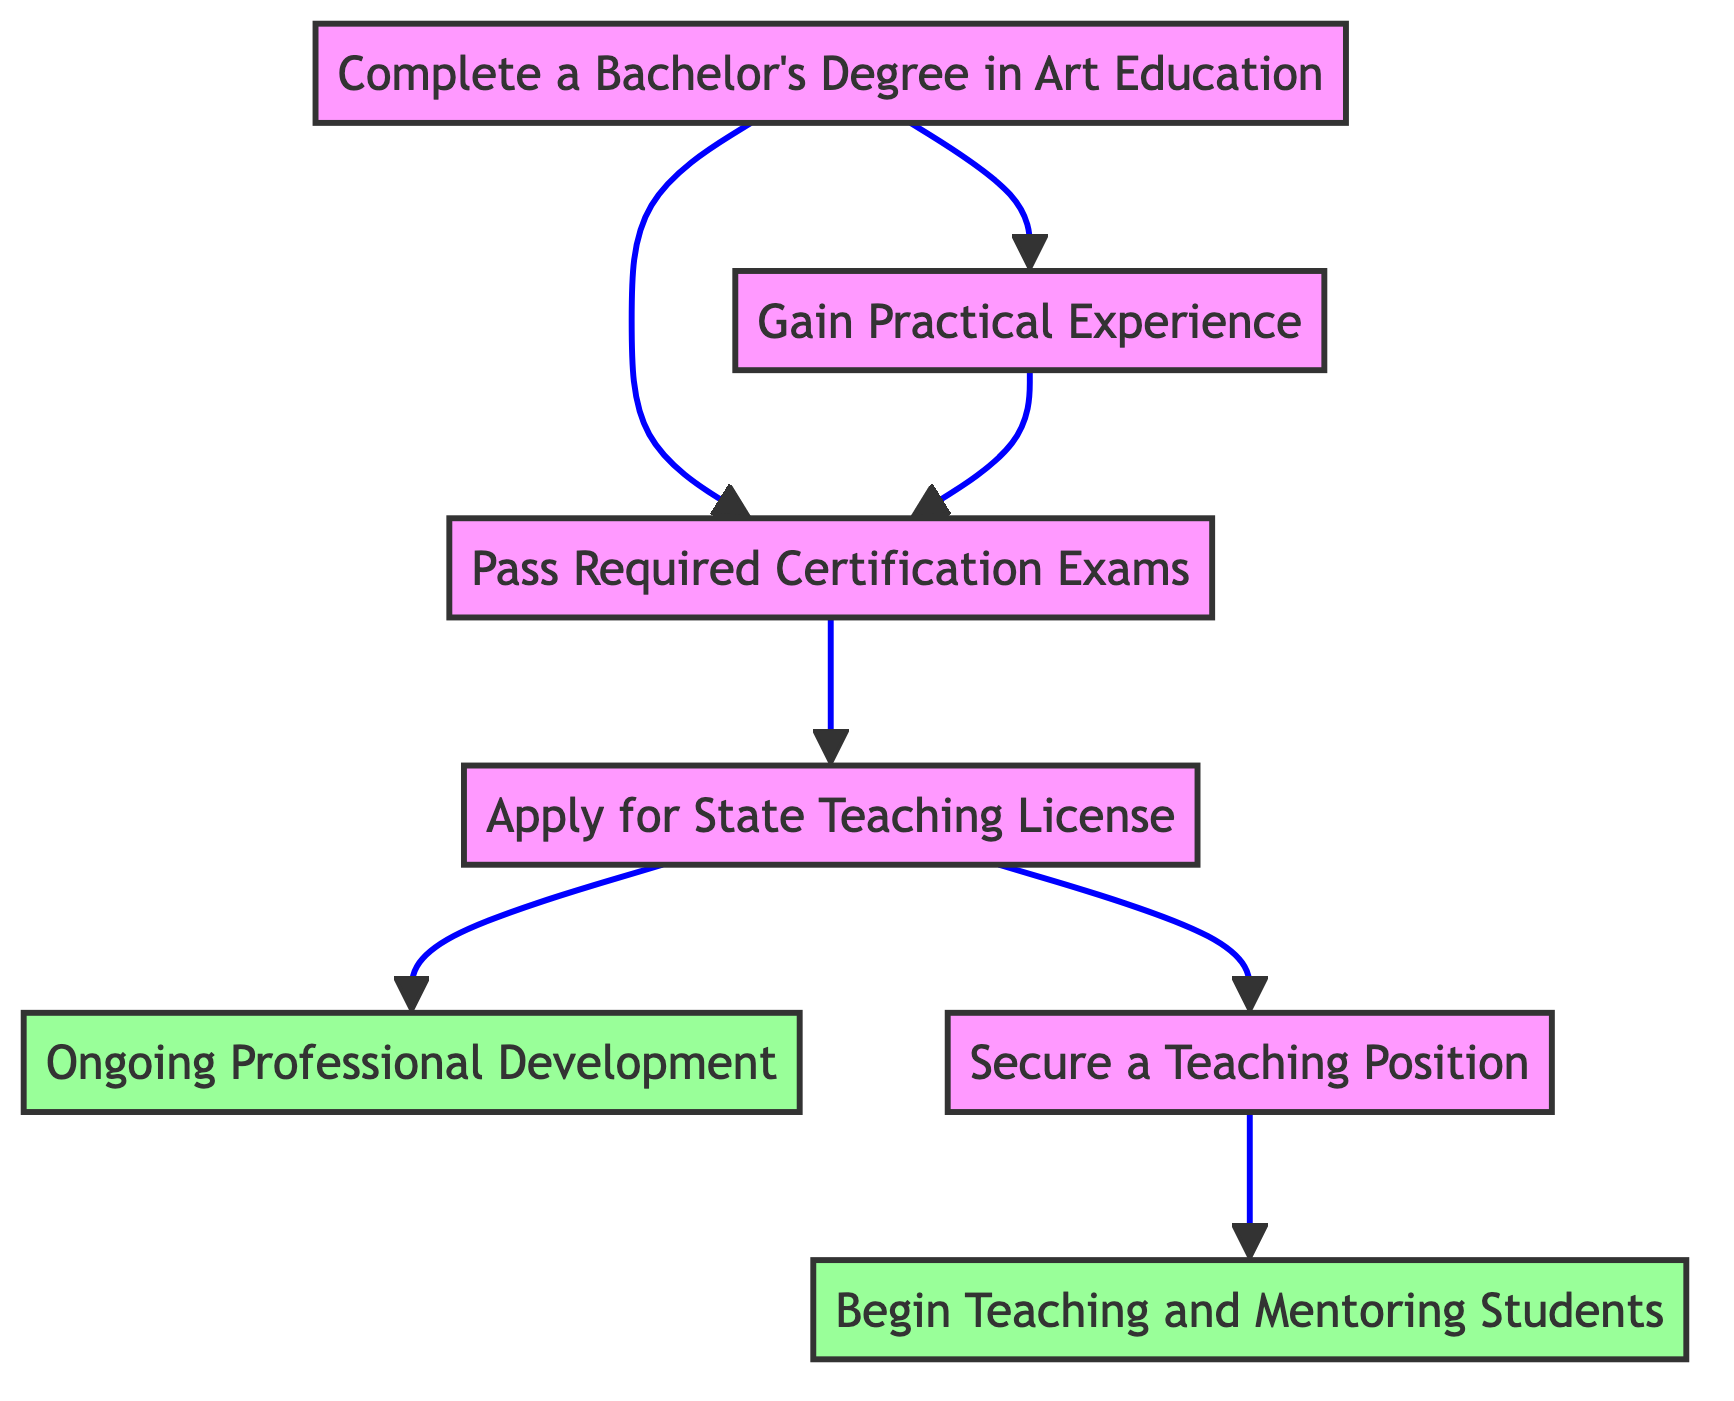What is the first step in becoming a certified art educator? The first step is "Complete a Bachelor's Degree in Art Education," which is the starting point in the flow chart and has no dependencies.
Answer: Complete a Bachelor's Degree in Art Education How many steps are shown in the diagram? The diagram consists of seven distinct steps from the beginning to the end of the process.
Answer: Seven What is required after passing the required certification exams? After passing the required certification exams, the next step is to "Apply for State Teaching License," which follows in the sequence from the exams.
Answer: Apply for State Teaching License What two steps are necessary before applying for a state teaching license? The two necessary preceding steps are "Pass Required Certification Exams" and "Gain Practical Experience," both of which must be completed first before applying.
Answer: Pass Required Certification Exams and Gain Practical Experience What does the "Ongoing Professional Development" step relate to? This step relates to "Apply for State Teaching License" as it is the subsequent action that follows after obtaining the state teaching license, indicating a commitment to continual improvement.
Answer: Apply for State Teaching License How does one begin teaching and mentoring students? One begins teaching and mentoring students by first securing a teaching position, as shown by the flow that connects to "Begin Teaching and Mentoring Students."
Answer: Secure a Teaching Position Which step illustrates the final goal in the pathway? The final goal is illustrated in the last step "Begin Teaching and Mentoring Students," representing the culmination of all prior steps.
Answer: Begin Teaching and Mentoring Students 